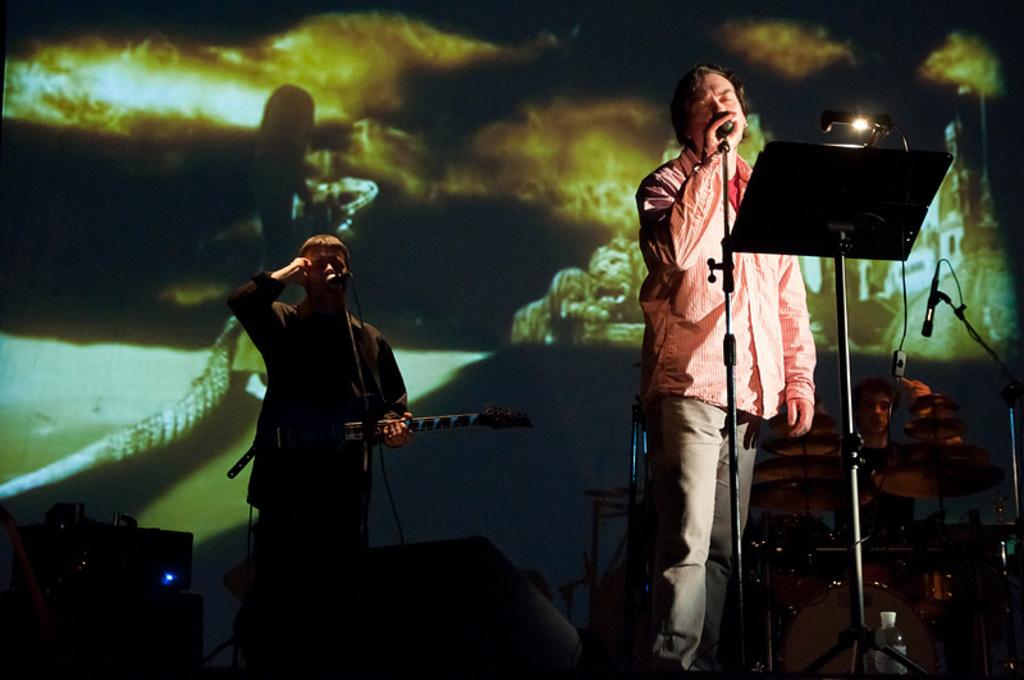What is happening on the stage in the image? There are people on the stage in the image, and some of them are singing and playing musical instruments. What are the people doing who are not playing instruments? The people who are not playing instruments are likely singing, as the facts mention that some people are singing. Can you describe the activities of the people on the stage? The people on the stage are either singing or playing musical instruments. What type of butter can be seen on the stage in the image? There is no butter present on the stage in the image. How many bears are visible on the stage in the image? There are no bears visible on the stage in the image. 